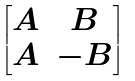Convert formula to latex. <formula><loc_0><loc_0><loc_500><loc_500>\begin{bmatrix} A & B \\ A & - B \end{bmatrix}</formula> 